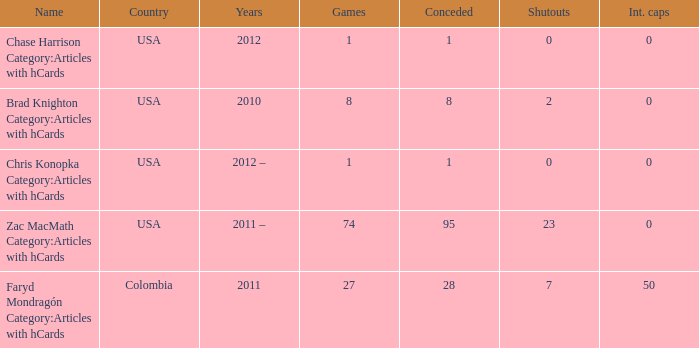What year is associated with the chase harrison category in articles containing hcards? 2012.0. 